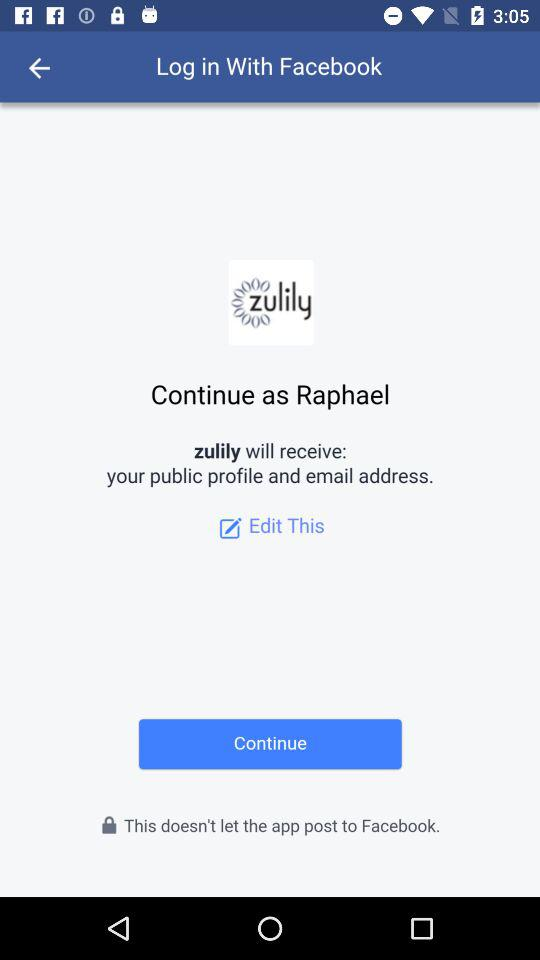What application is asking for permission? The application that is asking for permission is "zulily". 